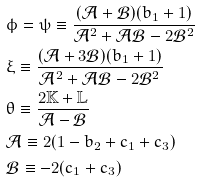Convert formula to latex. <formula><loc_0><loc_0><loc_500><loc_500>& \phi = \psi \equiv \frac { ( \mathcal { A } + \mathcal { B } ) ( b _ { 1 } + 1 ) } { \mathcal { A } ^ { 2 } + \mathcal { A } \mathcal { B } - 2 \mathcal { B } ^ { 2 } } \\ & \xi \equiv \frac { ( \mathcal { A } + 3 \mathcal { B } ) ( b _ { 1 } + 1 ) } { \mathcal { A } ^ { 2 } + \mathcal { A } \mathcal { B } - 2 \mathcal { B } ^ { 2 } } \\ & \theta \equiv \frac { 2 \mathbb { K } + \mathbb { L } } { \mathcal { A } - \mathcal { B } } \\ & \mathcal { A } \equiv 2 ( 1 - b _ { 2 } + c _ { 1 } + c _ { 3 } ) \\ & \mathcal { B } \equiv - 2 ( c _ { 1 } + c _ { 3 } )</formula> 